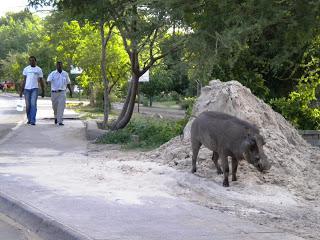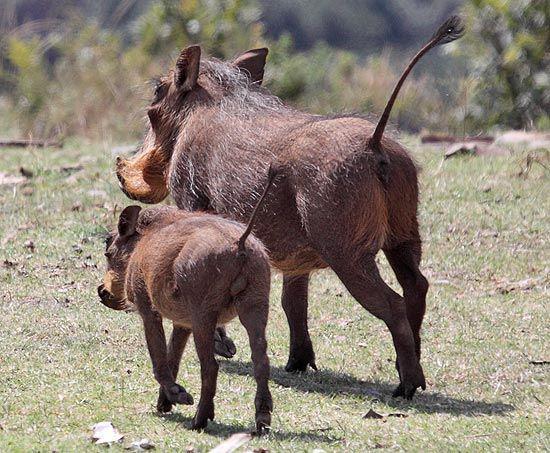The first image is the image on the left, the second image is the image on the right. Analyze the images presented: Is the assertion "In one image, there is at least one animal on top of another one." valid? Answer yes or no. No. The first image is the image on the left, the second image is the image on the right. Assess this claim about the two images: "Other animals are around the worthog". Correct or not? Answer yes or no. No. 